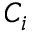Convert formula to latex. <formula><loc_0><loc_0><loc_500><loc_500>C _ { i }</formula> 